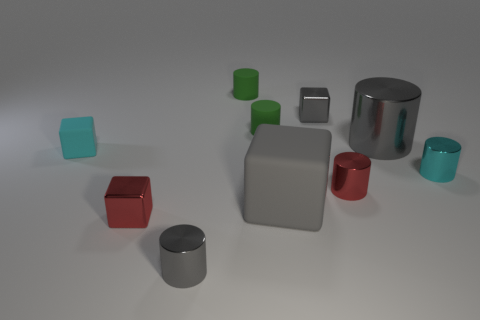There is a metal block that is in front of the tiny gray block; does it have the same color as the small metal object that is in front of the red metallic cube?
Make the answer very short. No. The large shiny object is what shape?
Your response must be concise. Cylinder. There is a cyan shiny object; how many small metallic cylinders are behind it?
Your answer should be compact. 0. How many cylinders have the same material as the red cube?
Make the answer very short. 4. Is the material of the small gray object behind the tiny cyan cylinder the same as the cyan cube?
Provide a succinct answer. No. Are there any large gray rubber things?
Your response must be concise. Yes. How big is the thing that is both on the right side of the big cube and behind the large gray cylinder?
Your response must be concise. Small. Is the number of small red metal objects that are behind the red cylinder greater than the number of metallic cubes that are on the right side of the large metal cylinder?
Ensure brevity in your answer.  No. The other cube that is the same color as the large matte block is what size?
Make the answer very short. Small. What color is the big cylinder?
Make the answer very short. Gray. 